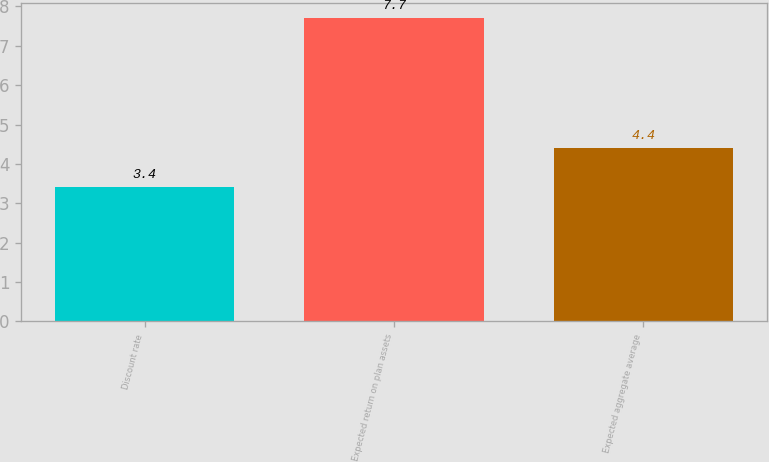<chart> <loc_0><loc_0><loc_500><loc_500><bar_chart><fcel>Discount rate<fcel>Expected return on plan assets<fcel>Expected aggregate average<nl><fcel>3.4<fcel>7.7<fcel>4.4<nl></chart> 